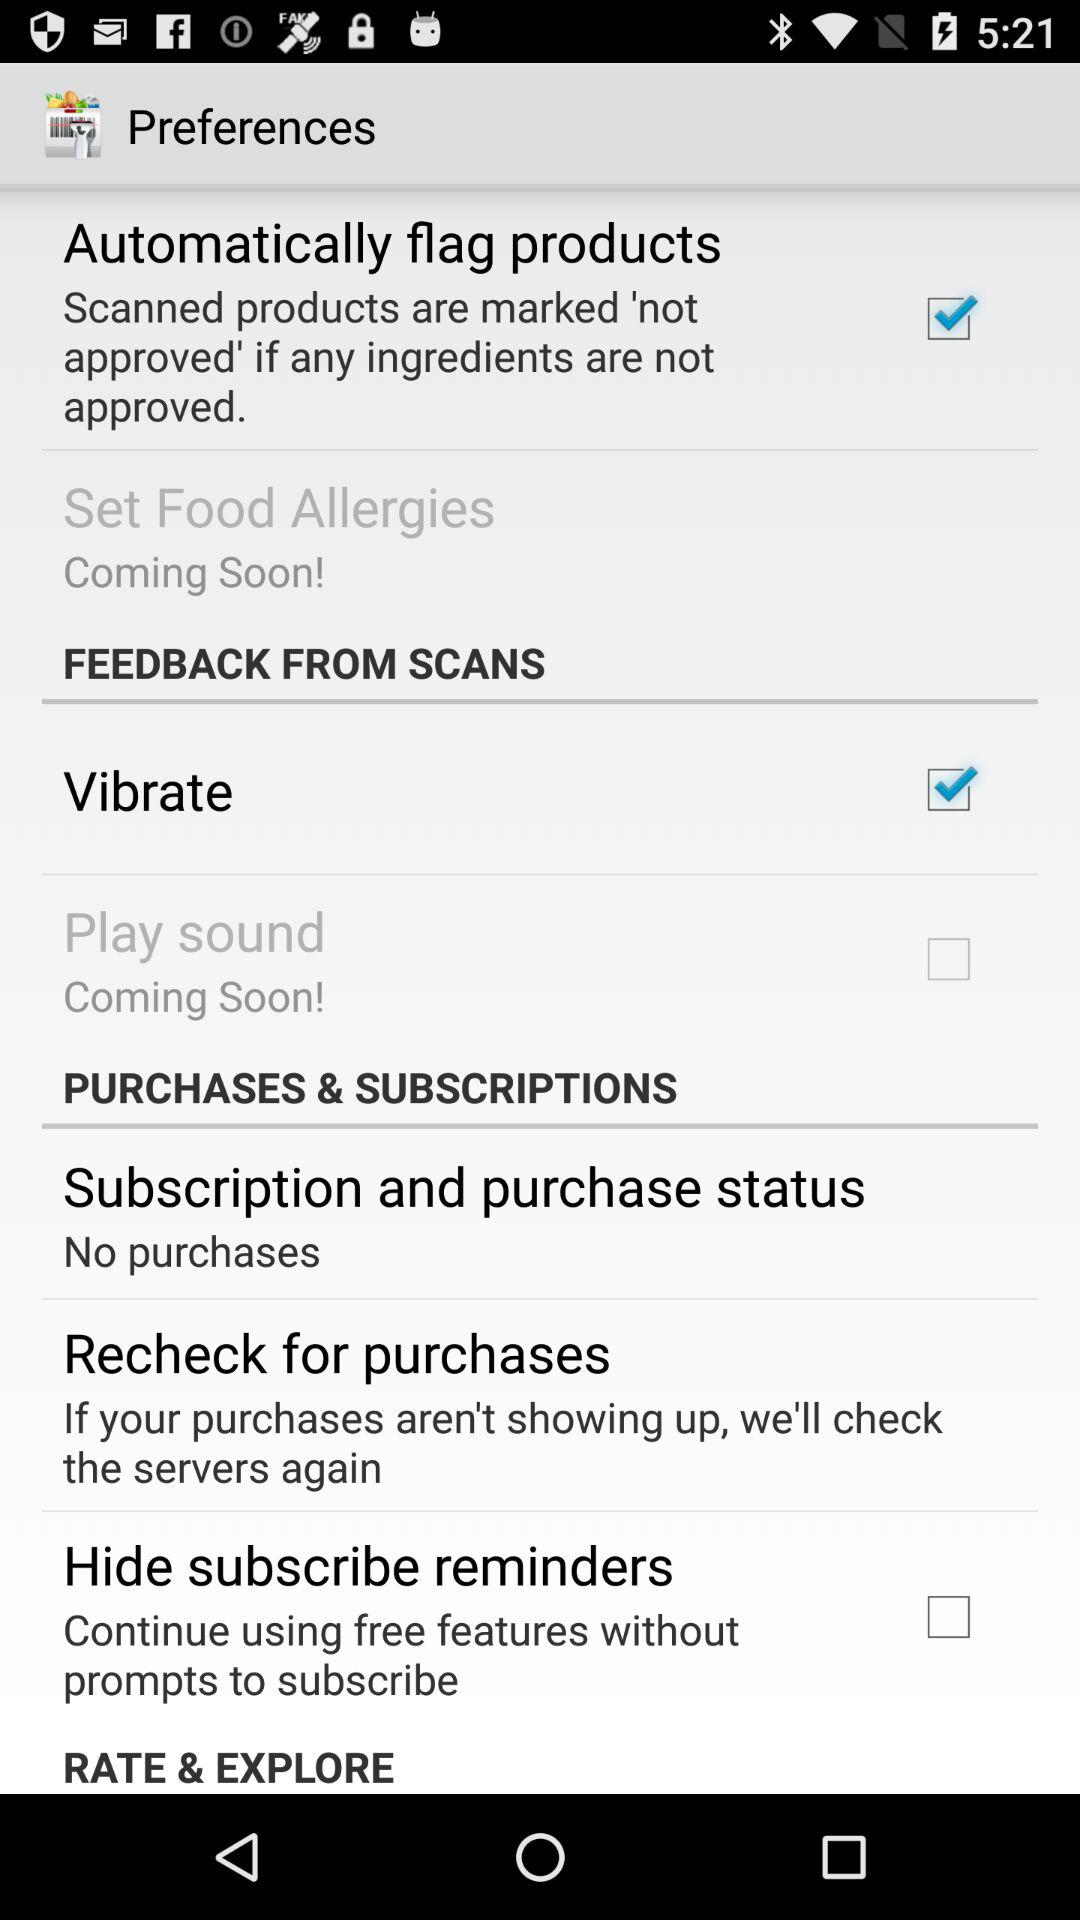How many purchases can be rechecked?
When the provided information is insufficient, respond with <no answer>. <no answer> 